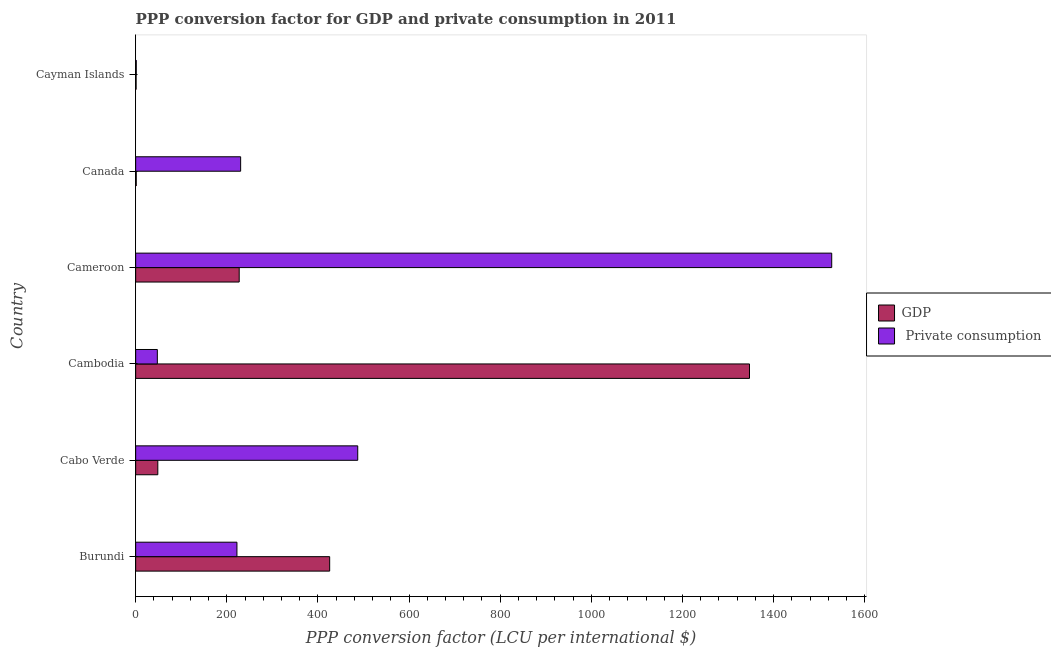Are the number of bars on each tick of the Y-axis equal?
Give a very brief answer. Yes. How many bars are there on the 5th tick from the top?
Your answer should be compact. 2. How many bars are there on the 5th tick from the bottom?
Give a very brief answer. 2. What is the ppp conversion factor for gdp in Cayman Islands?
Make the answer very short. 0.96. Across all countries, what is the maximum ppp conversion factor for private consumption?
Offer a terse response. 1527.56. Across all countries, what is the minimum ppp conversion factor for private consumption?
Make the answer very short. 1.28. In which country was the ppp conversion factor for private consumption maximum?
Make the answer very short. Cameroon. In which country was the ppp conversion factor for gdp minimum?
Provide a succinct answer. Cayman Islands. What is the total ppp conversion factor for gdp in the graph?
Offer a very short reply. 2050.89. What is the difference between the ppp conversion factor for gdp in Cambodia and that in Cayman Islands?
Keep it short and to the point. 1346.16. What is the difference between the ppp conversion factor for gdp in Canada and the ppp conversion factor for private consumption in Cambodia?
Make the answer very short. -46.33. What is the average ppp conversion factor for gdp per country?
Your response must be concise. 341.81. What is the difference between the ppp conversion factor for private consumption and ppp conversion factor for gdp in Burundi?
Make the answer very short. -203.53. In how many countries, is the ppp conversion factor for private consumption greater than 1120 LCU?
Ensure brevity in your answer.  1. What is the ratio of the ppp conversion factor for private consumption in Burundi to that in Cabo Verde?
Provide a short and direct response. 0.46. Is the ppp conversion factor for gdp in Burundi less than that in Canada?
Give a very brief answer. No. What is the difference between the highest and the second highest ppp conversion factor for private consumption?
Your answer should be very brief. 1040.23. What is the difference between the highest and the lowest ppp conversion factor for private consumption?
Provide a succinct answer. 1526.27. What does the 2nd bar from the top in Burundi represents?
Provide a succinct answer. GDP. What does the 1st bar from the bottom in Burundi represents?
Ensure brevity in your answer.  GDP. How many bars are there?
Offer a very short reply. 12. Does the graph contain grids?
Make the answer very short. No. How many legend labels are there?
Provide a succinct answer. 2. What is the title of the graph?
Keep it short and to the point. PPP conversion factor for GDP and private consumption in 2011. What is the label or title of the X-axis?
Keep it short and to the point. PPP conversion factor (LCU per international $). What is the label or title of the Y-axis?
Your answer should be very brief. Country. What is the PPP conversion factor (LCU per international $) of GDP in Burundi?
Give a very brief answer. 425.77. What is the PPP conversion factor (LCU per international $) of  Private consumption in Burundi?
Offer a very short reply. 222.24. What is the PPP conversion factor (LCU per international $) of GDP in Cabo Verde?
Make the answer very short. 48.59. What is the PPP conversion factor (LCU per international $) in  Private consumption in Cabo Verde?
Your answer should be compact. 487.33. What is the PPP conversion factor (LCU per international $) in GDP in Cambodia?
Provide a short and direct response. 1347.11. What is the PPP conversion factor (LCU per international $) of  Private consumption in Cambodia?
Your response must be concise. 47.57. What is the PPP conversion factor (LCU per international $) in GDP in Cameroon?
Offer a very short reply. 227.21. What is the PPP conversion factor (LCU per international $) in  Private consumption in Cameroon?
Provide a short and direct response. 1527.56. What is the PPP conversion factor (LCU per international $) of GDP in Canada?
Provide a short and direct response. 1.24. What is the PPP conversion factor (LCU per international $) of  Private consumption in Canada?
Make the answer very short. 230.38. What is the PPP conversion factor (LCU per international $) in GDP in Cayman Islands?
Ensure brevity in your answer.  0.96. What is the PPP conversion factor (LCU per international $) in  Private consumption in Cayman Islands?
Make the answer very short. 1.28. Across all countries, what is the maximum PPP conversion factor (LCU per international $) in GDP?
Offer a terse response. 1347.11. Across all countries, what is the maximum PPP conversion factor (LCU per international $) of  Private consumption?
Your answer should be compact. 1527.56. Across all countries, what is the minimum PPP conversion factor (LCU per international $) in GDP?
Your response must be concise. 0.96. Across all countries, what is the minimum PPP conversion factor (LCU per international $) in  Private consumption?
Offer a very short reply. 1.28. What is the total PPP conversion factor (LCU per international $) of GDP in the graph?
Give a very brief answer. 2050.89. What is the total PPP conversion factor (LCU per international $) of  Private consumption in the graph?
Your answer should be very brief. 2516.35. What is the difference between the PPP conversion factor (LCU per international $) in GDP in Burundi and that in Cabo Verde?
Give a very brief answer. 377.18. What is the difference between the PPP conversion factor (LCU per international $) in  Private consumption in Burundi and that in Cabo Verde?
Make the answer very short. -265.09. What is the difference between the PPP conversion factor (LCU per international $) of GDP in Burundi and that in Cambodia?
Your answer should be very brief. -921.35. What is the difference between the PPP conversion factor (LCU per international $) in  Private consumption in Burundi and that in Cambodia?
Your response must be concise. 174.68. What is the difference between the PPP conversion factor (LCU per international $) in GDP in Burundi and that in Cameroon?
Make the answer very short. 198.56. What is the difference between the PPP conversion factor (LCU per international $) of  Private consumption in Burundi and that in Cameroon?
Provide a succinct answer. -1305.32. What is the difference between the PPP conversion factor (LCU per international $) of GDP in Burundi and that in Canada?
Your answer should be very brief. 424.53. What is the difference between the PPP conversion factor (LCU per international $) in  Private consumption in Burundi and that in Canada?
Your response must be concise. -8.13. What is the difference between the PPP conversion factor (LCU per international $) in GDP in Burundi and that in Cayman Islands?
Your answer should be compact. 424.81. What is the difference between the PPP conversion factor (LCU per international $) of  Private consumption in Burundi and that in Cayman Islands?
Offer a terse response. 220.96. What is the difference between the PPP conversion factor (LCU per international $) in GDP in Cabo Verde and that in Cambodia?
Provide a short and direct response. -1298.52. What is the difference between the PPP conversion factor (LCU per international $) in  Private consumption in Cabo Verde and that in Cambodia?
Your response must be concise. 439.76. What is the difference between the PPP conversion factor (LCU per international $) of GDP in Cabo Verde and that in Cameroon?
Give a very brief answer. -178.62. What is the difference between the PPP conversion factor (LCU per international $) in  Private consumption in Cabo Verde and that in Cameroon?
Your answer should be very brief. -1040.23. What is the difference between the PPP conversion factor (LCU per international $) of GDP in Cabo Verde and that in Canada?
Provide a succinct answer. 47.35. What is the difference between the PPP conversion factor (LCU per international $) of  Private consumption in Cabo Verde and that in Canada?
Keep it short and to the point. 256.95. What is the difference between the PPP conversion factor (LCU per international $) of GDP in Cabo Verde and that in Cayman Islands?
Offer a very short reply. 47.63. What is the difference between the PPP conversion factor (LCU per international $) of  Private consumption in Cabo Verde and that in Cayman Islands?
Make the answer very short. 486.04. What is the difference between the PPP conversion factor (LCU per international $) of GDP in Cambodia and that in Cameroon?
Offer a terse response. 1119.9. What is the difference between the PPP conversion factor (LCU per international $) of  Private consumption in Cambodia and that in Cameroon?
Make the answer very short. -1479.99. What is the difference between the PPP conversion factor (LCU per international $) in GDP in Cambodia and that in Canada?
Keep it short and to the point. 1345.87. What is the difference between the PPP conversion factor (LCU per international $) of  Private consumption in Cambodia and that in Canada?
Provide a succinct answer. -182.81. What is the difference between the PPP conversion factor (LCU per international $) in GDP in Cambodia and that in Cayman Islands?
Ensure brevity in your answer.  1346.16. What is the difference between the PPP conversion factor (LCU per international $) of  Private consumption in Cambodia and that in Cayman Islands?
Provide a short and direct response. 46.28. What is the difference between the PPP conversion factor (LCU per international $) in GDP in Cameroon and that in Canada?
Ensure brevity in your answer.  225.97. What is the difference between the PPP conversion factor (LCU per international $) of  Private consumption in Cameroon and that in Canada?
Offer a very short reply. 1297.18. What is the difference between the PPP conversion factor (LCU per international $) of GDP in Cameroon and that in Cayman Islands?
Provide a short and direct response. 226.25. What is the difference between the PPP conversion factor (LCU per international $) of  Private consumption in Cameroon and that in Cayman Islands?
Offer a terse response. 1526.27. What is the difference between the PPP conversion factor (LCU per international $) in GDP in Canada and that in Cayman Islands?
Offer a very short reply. 0.28. What is the difference between the PPP conversion factor (LCU per international $) of  Private consumption in Canada and that in Cayman Islands?
Provide a short and direct response. 229.09. What is the difference between the PPP conversion factor (LCU per international $) of GDP in Burundi and the PPP conversion factor (LCU per international $) of  Private consumption in Cabo Verde?
Your response must be concise. -61.56. What is the difference between the PPP conversion factor (LCU per international $) of GDP in Burundi and the PPP conversion factor (LCU per international $) of  Private consumption in Cambodia?
Offer a very short reply. 378.2. What is the difference between the PPP conversion factor (LCU per international $) in GDP in Burundi and the PPP conversion factor (LCU per international $) in  Private consumption in Cameroon?
Offer a very short reply. -1101.79. What is the difference between the PPP conversion factor (LCU per international $) of GDP in Burundi and the PPP conversion factor (LCU per international $) of  Private consumption in Canada?
Provide a succinct answer. 195.39. What is the difference between the PPP conversion factor (LCU per international $) in GDP in Burundi and the PPP conversion factor (LCU per international $) in  Private consumption in Cayman Islands?
Give a very brief answer. 424.48. What is the difference between the PPP conversion factor (LCU per international $) in GDP in Cabo Verde and the PPP conversion factor (LCU per international $) in  Private consumption in Cambodia?
Your answer should be compact. 1.03. What is the difference between the PPP conversion factor (LCU per international $) of GDP in Cabo Verde and the PPP conversion factor (LCU per international $) of  Private consumption in Cameroon?
Your answer should be compact. -1478.97. What is the difference between the PPP conversion factor (LCU per international $) of GDP in Cabo Verde and the PPP conversion factor (LCU per international $) of  Private consumption in Canada?
Offer a terse response. -181.78. What is the difference between the PPP conversion factor (LCU per international $) of GDP in Cabo Verde and the PPP conversion factor (LCU per international $) of  Private consumption in Cayman Islands?
Your answer should be compact. 47.31. What is the difference between the PPP conversion factor (LCU per international $) of GDP in Cambodia and the PPP conversion factor (LCU per international $) of  Private consumption in Cameroon?
Your answer should be very brief. -180.44. What is the difference between the PPP conversion factor (LCU per international $) of GDP in Cambodia and the PPP conversion factor (LCU per international $) of  Private consumption in Canada?
Make the answer very short. 1116.74. What is the difference between the PPP conversion factor (LCU per international $) in GDP in Cambodia and the PPP conversion factor (LCU per international $) in  Private consumption in Cayman Islands?
Provide a short and direct response. 1345.83. What is the difference between the PPP conversion factor (LCU per international $) of GDP in Cameroon and the PPP conversion factor (LCU per international $) of  Private consumption in Canada?
Keep it short and to the point. -3.16. What is the difference between the PPP conversion factor (LCU per international $) in GDP in Cameroon and the PPP conversion factor (LCU per international $) in  Private consumption in Cayman Islands?
Ensure brevity in your answer.  225.93. What is the difference between the PPP conversion factor (LCU per international $) in GDP in Canada and the PPP conversion factor (LCU per international $) in  Private consumption in Cayman Islands?
Your response must be concise. -0.04. What is the average PPP conversion factor (LCU per international $) of GDP per country?
Provide a succinct answer. 341.81. What is the average PPP conversion factor (LCU per international $) in  Private consumption per country?
Your answer should be very brief. 419.39. What is the difference between the PPP conversion factor (LCU per international $) in GDP and PPP conversion factor (LCU per international $) in  Private consumption in Burundi?
Keep it short and to the point. 203.53. What is the difference between the PPP conversion factor (LCU per international $) of GDP and PPP conversion factor (LCU per international $) of  Private consumption in Cabo Verde?
Keep it short and to the point. -438.74. What is the difference between the PPP conversion factor (LCU per international $) of GDP and PPP conversion factor (LCU per international $) of  Private consumption in Cambodia?
Your response must be concise. 1299.55. What is the difference between the PPP conversion factor (LCU per international $) of GDP and PPP conversion factor (LCU per international $) of  Private consumption in Cameroon?
Provide a succinct answer. -1300.35. What is the difference between the PPP conversion factor (LCU per international $) in GDP and PPP conversion factor (LCU per international $) in  Private consumption in Canada?
Provide a succinct answer. -229.14. What is the difference between the PPP conversion factor (LCU per international $) in GDP and PPP conversion factor (LCU per international $) in  Private consumption in Cayman Islands?
Keep it short and to the point. -0.33. What is the ratio of the PPP conversion factor (LCU per international $) of GDP in Burundi to that in Cabo Verde?
Provide a short and direct response. 8.76. What is the ratio of the PPP conversion factor (LCU per international $) in  Private consumption in Burundi to that in Cabo Verde?
Ensure brevity in your answer.  0.46. What is the ratio of the PPP conversion factor (LCU per international $) of GDP in Burundi to that in Cambodia?
Offer a very short reply. 0.32. What is the ratio of the PPP conversion factor (LCU per international $) in  Private consumption in Burundi to that in Cambodia?
Offer a terse response. 4.67. What is the ratio of the PPP conversion factor (LCU per international $) in GDP in Burundi to that in Cameroon?
Your response must be concise. 1.87. What is the ratio of the PPP conversion factor (LCU per international $) of  Private consumption in Burundi to that in Cameroon?
Offer a very short reply. 0.15. What is the ratio of the PPP conversion factor (LCU per international $) in GDP in Burundi to that in Canada?
Provide a short and direct response. 343.39. What is the ratio of the PPP conversion factor (LCU per international $) in  Private consumption in Burundi to that in Canada?
Provide a succinct answer. 0.96. What is the ratio of the PPP conversion factor (LCU per international $) of GDP in Burundi to that in Cayman Islands?
Keep it short and to the point. 444.06. What is the ratio of the PPP conversion factor (LCU per international $) of  Private consumption in Burundi to that in Cayman Islands?
Offer a very short reply. 173.01. What is the ratio of the PPP conversion factor (LCU per international $) in GDP in Cabo Verde to that in Cambodia?
Ensure brevity in your answer.  0.04. What is the ratio of the PPP conversion factor (LCU per international $) of  Private consumption in Cabo Verde to that in Cambodia?
Your answer should be compact. 10.25. What is the ratio of the PPP conversion factor (LCU per international $) in GDP in Cabo Verde to that in Cameroon?
Ensure brevity in your answer.  0.21. What is the ratio of the PPP conversion factor (LCU per international $) of  Private consumption in Cabo Verde to that in Cameroon?
Your answer should be compact. 0.32. What is the ratio of the PPP conversion factor (LCU per international $) in GDP in Cabo Verde to that in Canada?
Your answer should be very brief. 39.19. What is the ratio of the PPP conversion factor (LCU per international $) in  Private consumption in Cabo Verde to that in Canada?
Offer a very short reply. 2.12. What is the ratio of the PPP conversion factor (LCU per international $) in GDP in Cabo Verde to that in Cayman Islands?
Ensure brevity in your answer.  50.68. What is the ratio of the PPP conversion factor (LCU per international $) of  Private consumption in Cabo Verde to that in Cayman Islands?
Keep it short and to the point. 379.37. What is the ratio of the PPP conversion factor (LCU per international $) in GDP in Cambodia to that in Cameroon?
Ensure brevity in your answer.  5.93. What is the ratio of the PPP conversion factor (LCU per international $) in  Private consumption in Cambodia to that in Cameroon?
Keep it short and to the point. 0.03. What is the ratio of the PPP conversion factor (LCU per international $) of GDP in Cambodia to that in Canada?
Your answer should be very brief. 1086.47. What is the ratio of the PPP conversion factor (LCU per international $) of  Private consumption in Cambodia to that in Canada?
Your response must be concise. 0.21. What is the ratio of the PPP conversion factor (LCU per international $) in GDP in Cambodia to that in Cayman Islands?
Provide a short and direct response. 1405. What is the ratio of the PPP conversion factor (LCU per international $) in  Private consumption in Cambodia to that in Cayman Islands?
Give a very brief answer. 37.03. What is the ratio of the PPP conversion factor (LCU per international $) of GDP in Cameroon to that in Canada?
Make the answer very short. 183.25. What is the ratio of the PPP conversion factor (LCU per international $) of  Private consumption in Cameroon to that in Canada?
Make the answer very short. 6.63. What is the ratio of the PPP conversion factor (LCU per international $) of GDP in Cameroon to that in Cayman Islands?
Give a very brief answer. 236.98. What is the ratio of the PPP conversion factor (LCU per international $) in  Private consumption in Cameroon to that in Cayman Islands?
Provide a short and direct response. 1189.15. What is the ratio of the PPP conversion factor (LCU per international $) of GDP in Canada to that in Cayman Islands?
Make the answer very short. 1.29. What is the ratio of the PPP conversion factor (LCU per international $) of  Private consumption in Canada to that in Cayman Islands?
Give a very brief answer. 179.34. What is the difference between the highest and the second highest PPP conversion factor (LCU per international $) in GDP?
Ensure brevity in your answer.  921.35. What is the difference between the highest and the second highest PPP conversion factor (LCU per international $) of  Private consumption?
Provide a succinct answer. 1040.23. What is the difference between the highest and the lowest PPP conversion factor (LCU per international $) in GDP?
Provide a succinct answer. 1346.16. What is the difference between the highest and the lowest PPP conversion factor (LCU per international $) of  Private consumption?
Provide a short and direct response. 1526.27. 